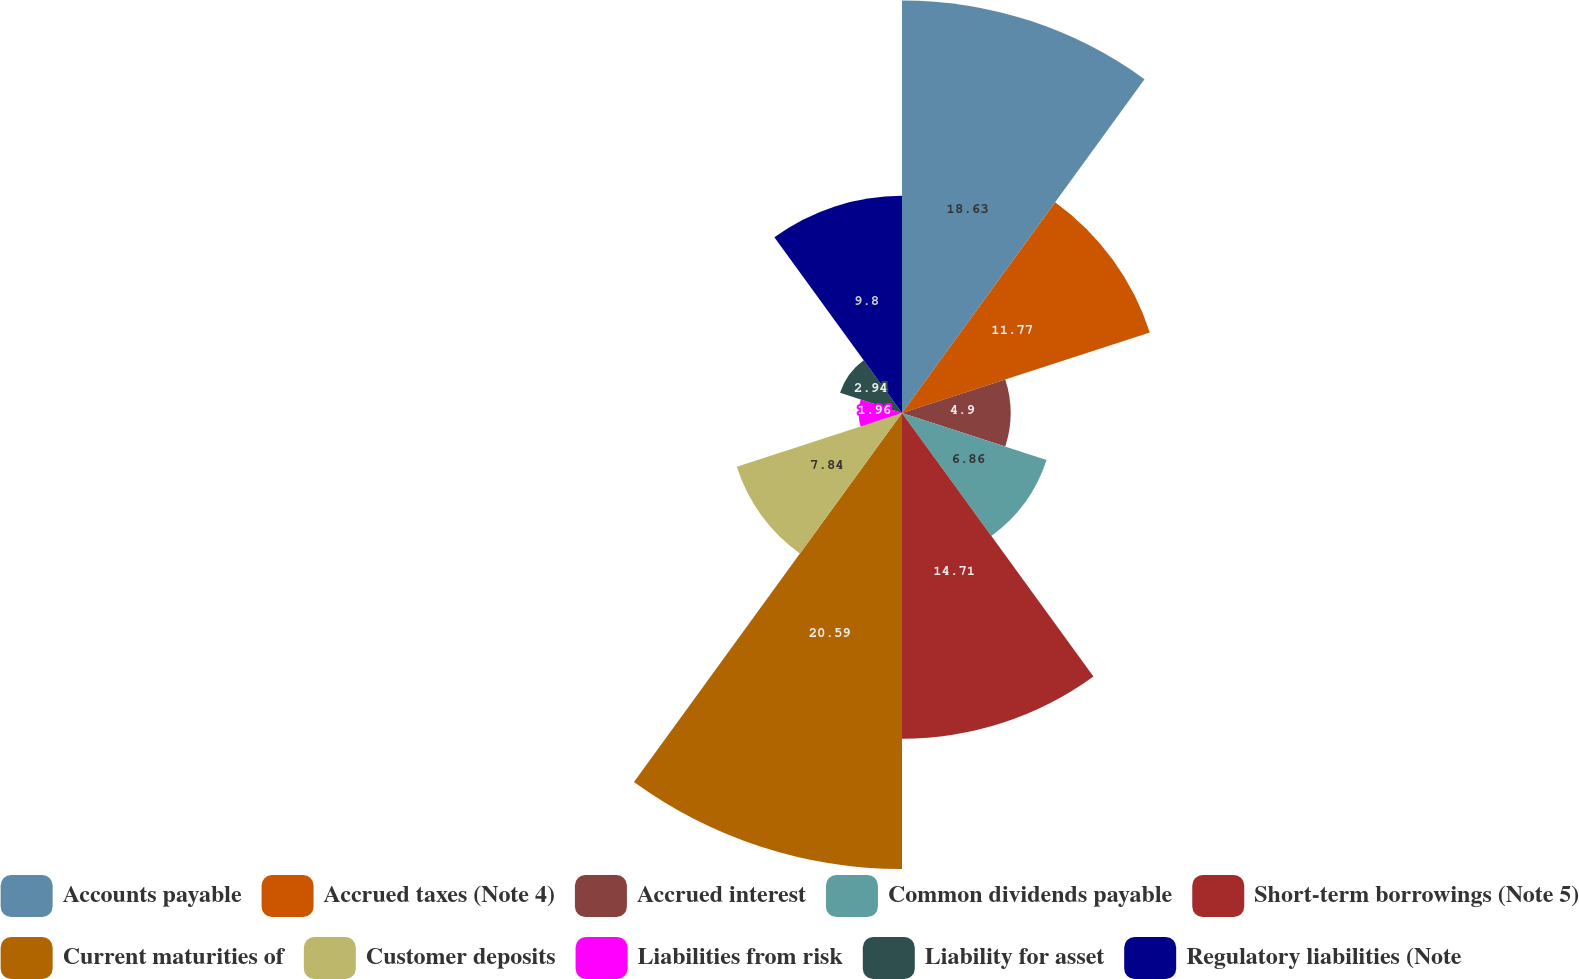Convert chart to OTSL. <chart><loc_0><loc_0><loc_500><loc_500><pie_chart><fcel>Accounts payable<fcel>Accrued taxes (Note 4)<fcel>Accrued interest<fcel>Common dividends payable<fcel>Short-term borrowings (Note 5)<fcel>Current maturities of<fcel>Customer deposits<fcel>Liabilities from risk<fcel>Liability for asset<fcel>Regulatory liabilities (Note<nl><fcel>18.62%<fcel>11.76%<fcel>4.9%<fcel>6.86%<fcel>14.7%<fcel>20.58%<fcel>7.84%<fcel>1.96%<fcel>2.94%<fcel>9.8%<nl></chart> 